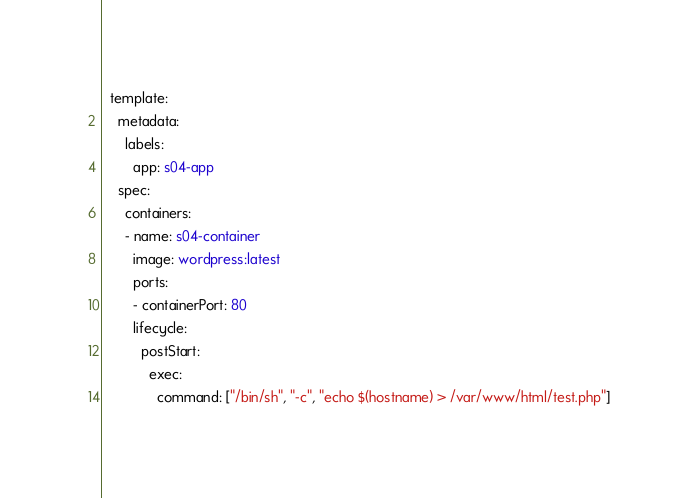Convert code to text. <code><loc_0><loc_0><loc_500><loc_500><_YAML_>  template:
    metadata:
      labels:
        app: s04-app
    spec:
      containers:
      - name: s04-container
        image: wordpress:latest
        ports:
        - containerPort: 80
        lifecycle:
          postStart:
            exec:
              command: ["/bin/sh", "-c", "echo $(hostname) > /var/www/html/test.php"]
</code> 